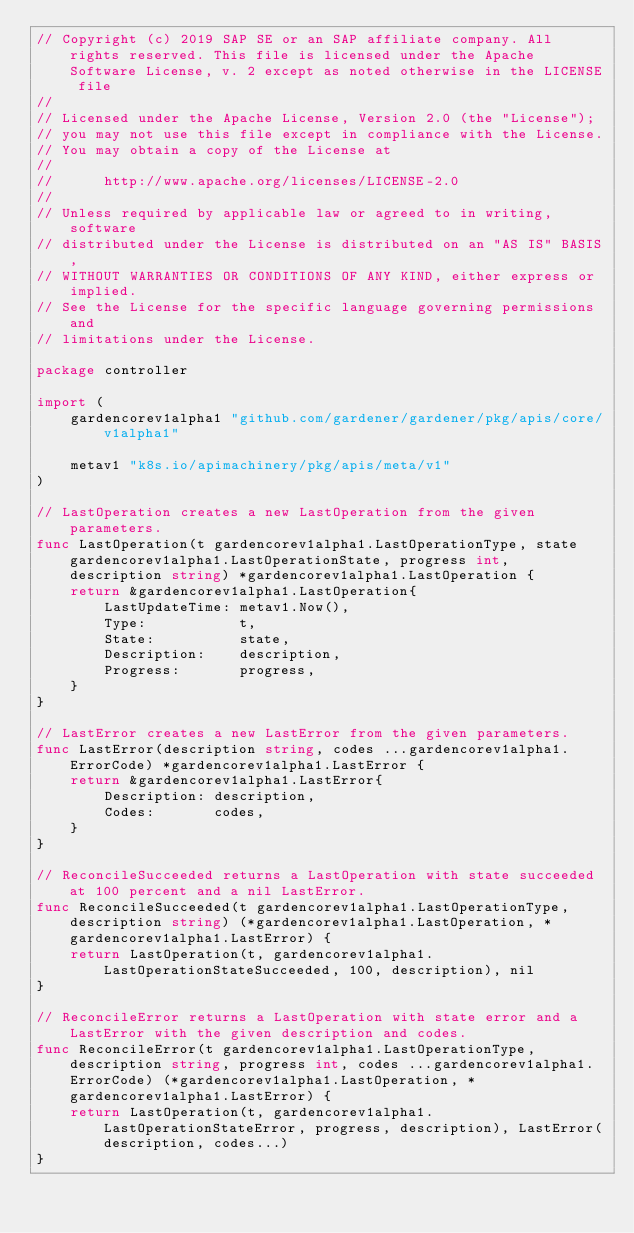Convert code to text. <code><loc_0><loc_0><loc_500><loc_500><_Go_>// Copyright (c) 2019 SAP SE or an SAP affiliate company. All rights reserved. This file is licensed under the Apache Software License, v. 2 except as noted otherwise in the LICENSE file
//
// Licensed under the Apache License, Version 2.0 (the "License");
// you may not use this file except in compliance with the License.
// You may obtain a copy of the License at
//
//      http://www.apache.org/licenses/LICENSE-2.0
//
// Unless required by applicable law or agreed to in writing, software
// distributed under the License is distributed on an "AS IS" BASIS,
// WITHOUT WARRANTIES OR CONDITIONS OF ANY KIND, either express or implied.
// See the License for the specific language governing permissions and
// limitations under the License.

package controller

import (
	gardencorev1alpha1 "github.com/gardener/gardener/pkg/apis/core/v1alpha1"

	metav1 "k8s.io/apimachinery/pkg/apis/meta/v1"
)

// LastOperation creates a new LastOperation from the given parameters.
func LastOperation(t gardencorev1alpha1.LastOperationType, state gardencorev1alpha1.LastOperationState, progress int, description string) *gardencorev1alpha1.LastOperation {
	return &gardencorev1alpha1.LastOperation{
		LastUpdateTime: metav1.Now(),
		Type:           t,
		State:          state,
		Description:    description,
		Progress:       progress,
	}
}

// LastError creates a new LastError from the given parameters.
func LastError(description string, codes ...gardencorev1alpha1.ErrorCode) *gardencorev1alpha1.LastError {
	return &gardencorev1alpha1.LastError{
		Description: description,
		Codes:       codes,
	}
}

// ReconcileSucceeded returns a LastOperation with state succeeded at 100 percent and a nil LastError.
func ReconcileSucceeded(t gardencorev1alpha1.LastOperationType, description string) (*gardencorev1alpha1.LastOperation, *gardencorev1alpha1.LastError) {
	return LastOperation(t, gardencorev1alpha1.LastOperationStateSucceeded, 100, description), nil
}

// ReconcileError returns a LastOperation with state error and a LastError with the given description and codes.
func ReconcileError(t gardencorev1alpha1.LastOperationType, description string, progress int, codes ...gardencorev1alpha1.ErrorCode) (*gardencorev1alpha1.LastOperation, *gardencorev1alpha1.LastError) {
	return LastOperation(t, gardencorev1alpha1.LastOperationStateError, progress, description), LastError(description, codes...)
}
</code> 